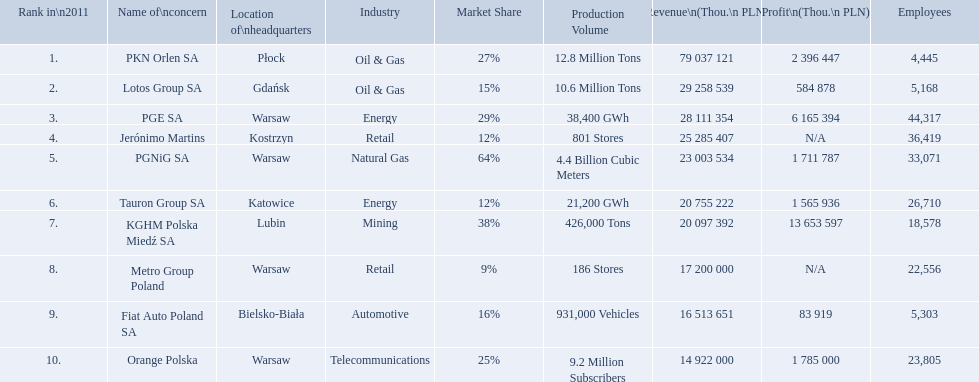What company has 28 111 354 thou.in revenue? PGE SA. What revenue does lotus group sa have? 29 258 539. Who has the next highest revenue than lotus group sa? PKN Orlen SA. What are the names of the major companies of poland? PKN Orlen SA, Lotos Group SA, PGE SA, Jerónimo Martins, PGNiG SA, Tauron Group SA, KGHM Polska Miedź SA, Metro Group Poland, Fiat Auto Poland SA, Orange Polska. What are the revenues of those companies in thou. pln? PKN Orlen SA, 79 037 121, Lotos Group SA, 29 258 539, PGE SA, 28 111 354, Jerónimo Martins, 25 285 407, PGNiG SA, 23 003 534, Tauron Group SA, 20 755 222, KGHM Polska Miedź SA, 20 097 392, Metro Group Poland, 17 200 000, Fiat Auto Poland SA, 16 513 651, Orange Polska, 14 922 000. Which of these revenues is greater than 75 000 000 thou. pln? 79 037 121. Which company has a revenue equal to 79 037 121 thou pln? PKN Orlen SA. What companies are listed? PKN Orlen SA, Lotos Group SA, PGE SA, Jerónimo Martins, PGNiG SA, Tauron Group SA, KGHM Polska Miedź SA, Metro Group Poland, Fiat Auto Poland SA, Orange Polska. What are the company's revenues? 79 037 121, 29 258 539, 28 111 354, 25 285 407, 23 003 534, 20 755 222, 20 097 392, 17 200 000, 16 513 651, 14 922 000. Which company has the greatest revenue? PKN Orlen SA. 